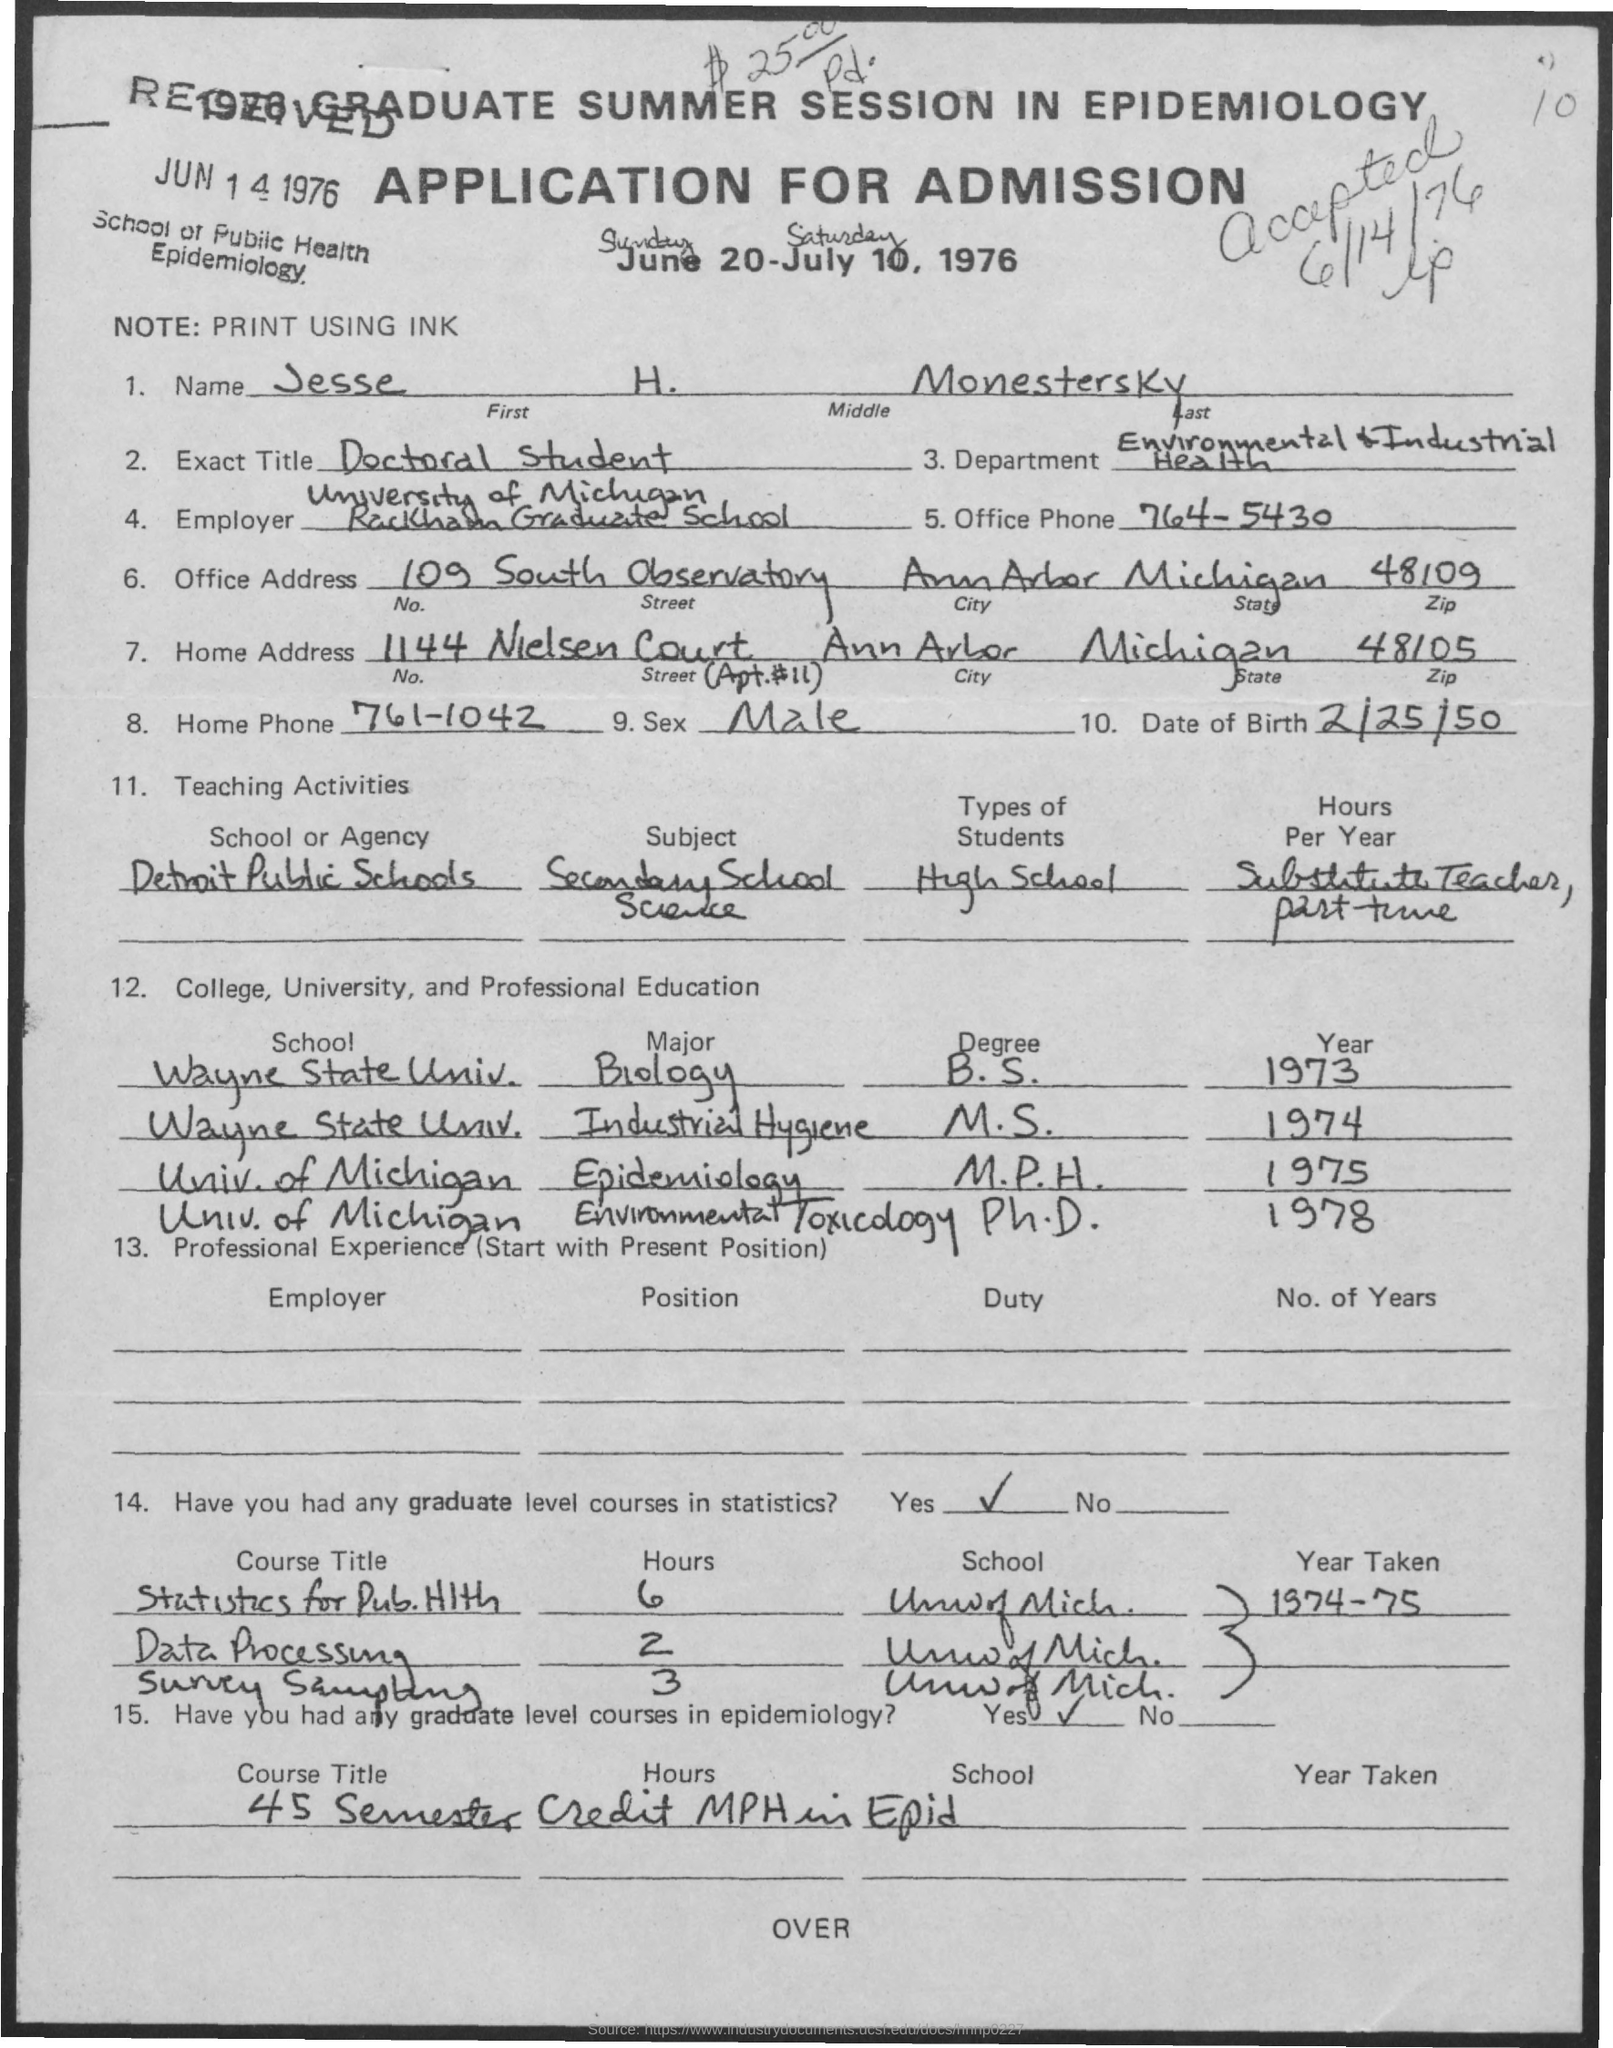Give some essential details in this illustration. The date of birth is February 25, 1950. I, as a doctoral student, would like to know the exact title of my position. The name mentioned is Jesse H. Monestersky. The zipcode of the office address is 48109. The zip code of the home address located in 48105. 